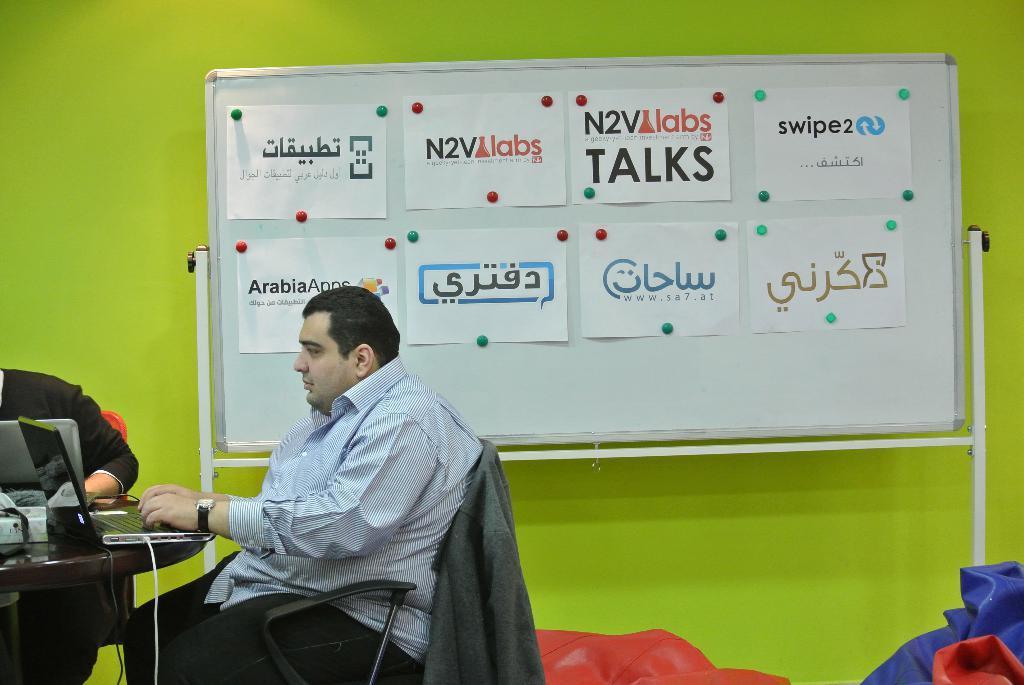Could you give a brief overview of what you see in this image? On this whiteboard there are different type of posters. This man is sitting on a chair and kept his hand on the laptop. On this table there are laptops and box. These are bean bags. On this chair there is a jacket. The wall is in green color. 